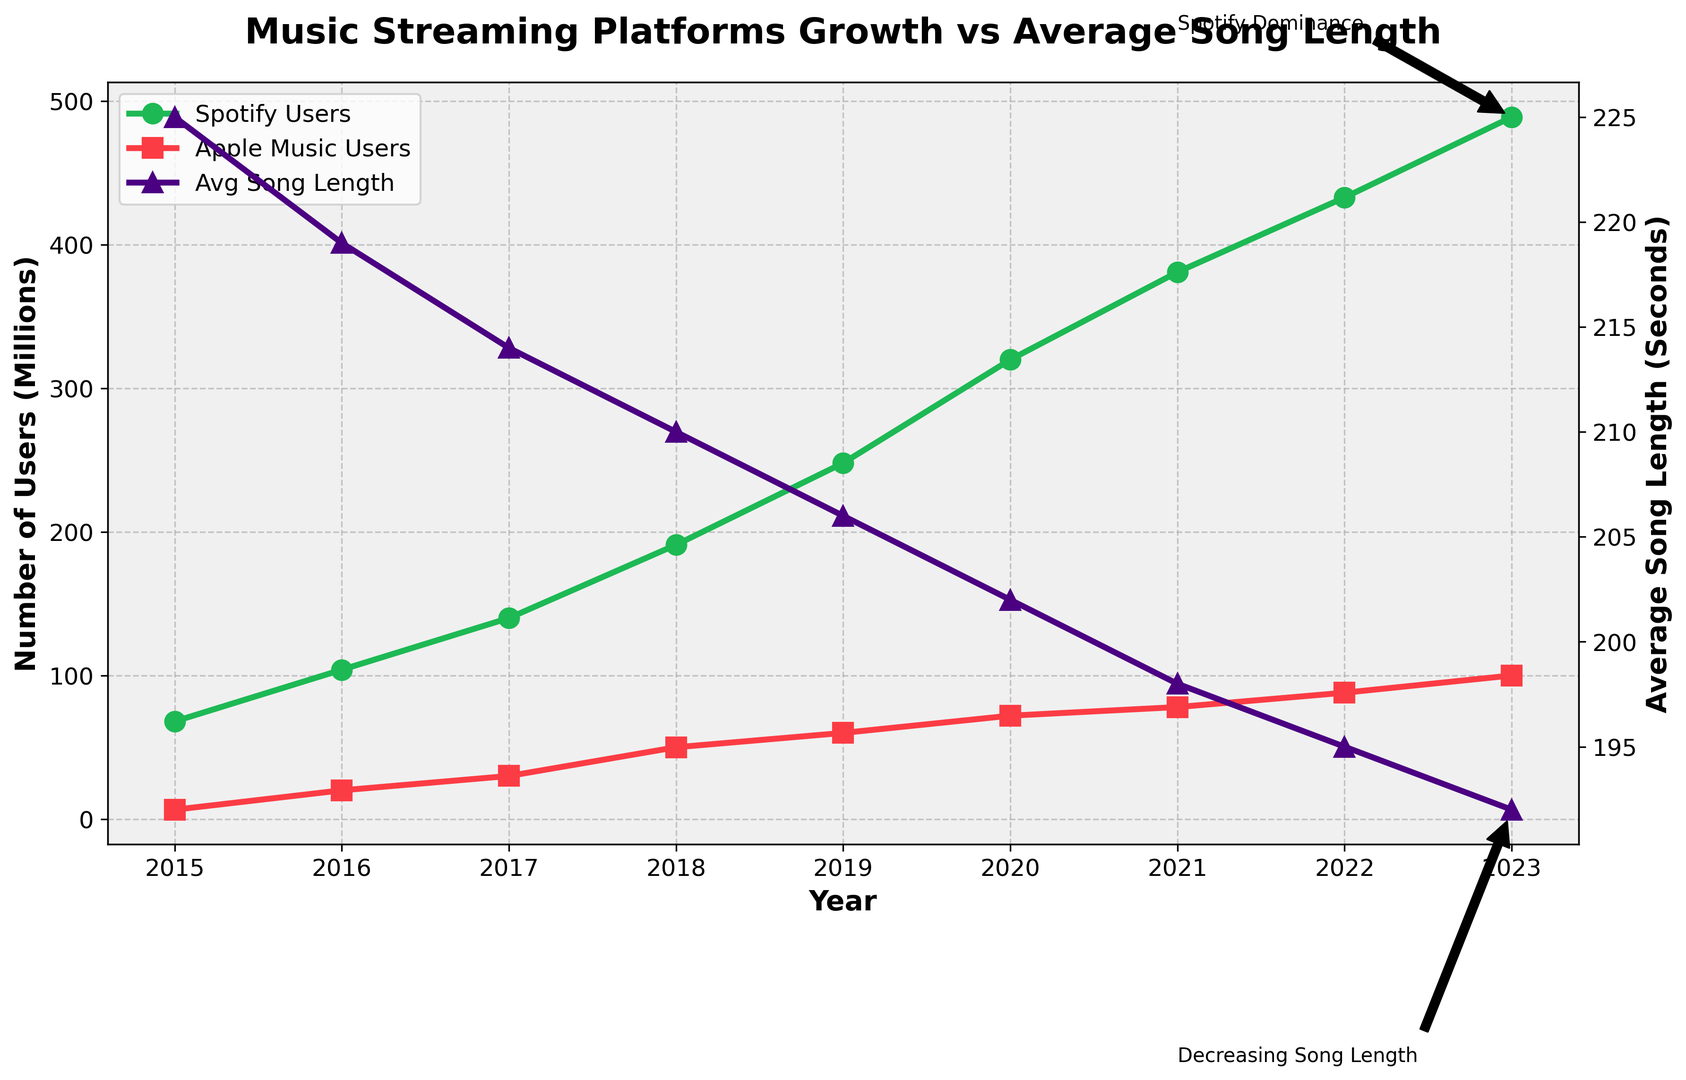How has the number of Spotify users changed from 2015 to 2023? The plot shows the number of Spotify users represented by a green line with circles. From 2015 to 2023, Spotify users increased. In 2015, there were 68 million users, and by 2023, this number reached 489 million.
Answer: Increased by 421 million Which platform had more users in 2021, Spotify or Apple Music? Looking at the year 2021 on the plot, the green line with circles represents Spotify users, and the red line with squares represents Apple Music users. In 2021, Spotify had 381 million users, while Apple Music had 78 million. Thus, Spotify had more users.
Answer: Spotify What color represents the average song length on the plot? The plot uses different colors for different data. The line with average song length is indicated by a purple color, shown on the secondary y-axis.
Answer: Purple By how many seconds did the average song length decrease from 2015 to 2023? The average song length is shown by a purple line with triangles. In 2015, the average song length was 225 seconds, and in 2023, it was 192 seconds. The decrease is 225 - 192 = 33 seconds.
Answer: 33 seconds What was the average song length in 2020? The purple line with triangles represents average song length. In the year 2020, this line indicates an average song length of 202 seconds.
Answer: 202 seconds Is there a visible trend in the average song length from 2015 to 2023? The plot shows the purple line with triangles gradually declining from 2015 to 2023, indicating that the average song length has decreased over these years.
Answer: Decreasing In which year did Apple Music users reach 100 million? The red line with squares represents Apple Music users. By following the line, it reaches 100 million in the year 2023.
Answer: 2023 How many more Spotify users were there in 2019 compared to 2016? The green line with circles shows the number of Spotify users. In 2016, there were 104 million users, and in 2019, there were 248 million users. The difference is 248 - 104 = 144 million users.
Answer: 144 million Did the number of Spotify users always increase every year from 2015 to 2023? Observing the green line with circles from 2015 to 2023, there are no decreases in values. The number of Spotify users increased every year.
Answer: Yes 